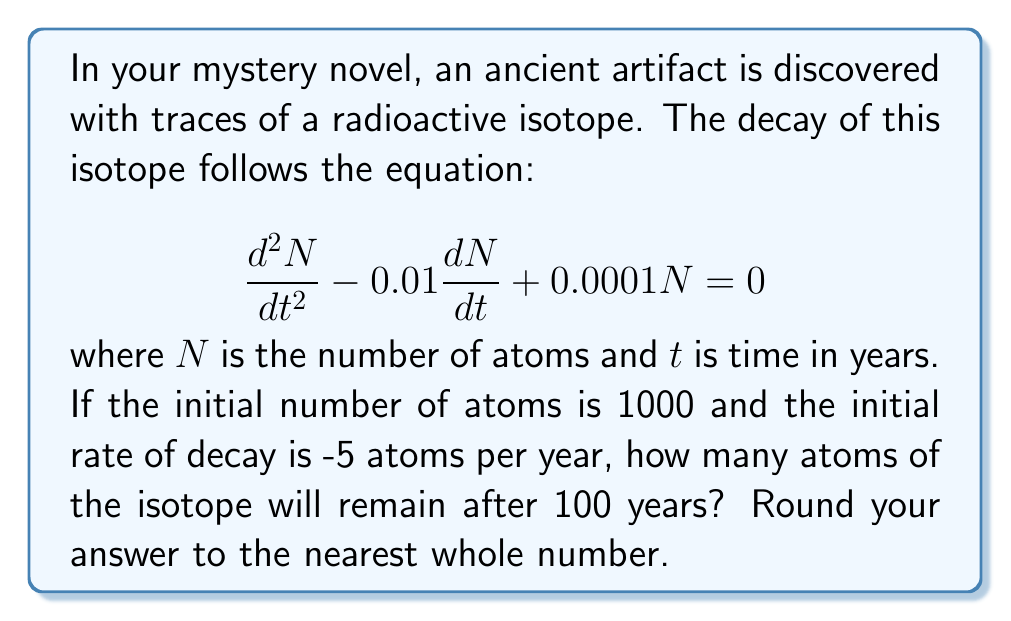Help me with this question. Let's solve this step-by-step:

1) The given equation is a second-order linear differential equation with constant coefficients:

   $$\frac{d^2N}{dt^2} - 0.01\frac{dN}{dt} + 0.0001N = 0$$

2) The characteristic equation is:
   
   $$r^2 - 0.01r + 0.0001 = 0$$

3) Solving this quadratic equation:
   
   $$r = \frac{0.01 \pm \sqrt{0.0001 - 0.0004}}{2} = 0.005 \pm 0.005$$

4) So, $r_1 = 0.01$ and $r_2 = 0$

5) The general solution is:
   
   $$N(t) = c_1e^{0.01t} + c_2$$

6) Given initial conditions:
   $N(0) = 1000$ and $N'(0) = -5$

7) Using these conditions:
   
   $1000 = c_1 + c_2$
   $-5 = 0.01c_1$

8) Solving these equations:
   
   $c_1 = -500$ and $c_2 = 1500$

9) Therefore, the particular solution is:
   
   $$N(t) = -500e^{0.01t} + 1500$$

10) To find $N(100)$:
    
    $$N(100) = -500e^{1} + 1500 = -500(2.718282) + 1500 = 140.859$$

11) Rounding to the nearest whole number: 141
Answer: 141 atoms 